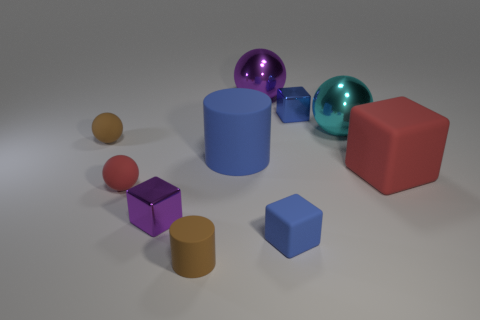Is there a small purple shiny object?
Ensure brevity in your answer.  Yes. There is a blue metal thing; is its shape the same as the tiny brown rubber thing that is in front of the large red rubber object?
Ensure brevity in your answer.  No. There is a matte cube behind the metal block that is to the left of the small brown matte object that is in front of the red block; what is its color?
Offer a very short reply. Red. There is a small blue shiny block; are there any big cyan metal things left of it?
Provide a succinct answer. No. There is a metal thing that is the same color as the small matte cube; what is its size?
Your answer should be very brief. Small. Are there any blue cylinders made of the same material as the brown sphere?
Provide a short and direct response. Yes. The big matte cylinder is what color?
Provide a succinct answer. Blue. There is a red object that is right of the red ball; does it have the same shape as the tiny purple thing?
Make the answer very short. Yes. What is the shape of the red thing to the right of the object that is behind the blue block that is to the right of the tiny blue matte object?
Offer a very short reply. Cube. There is a tiny cube behind the tiny brown rubber ball; what material is it?
Make the answer very short. Metal. 